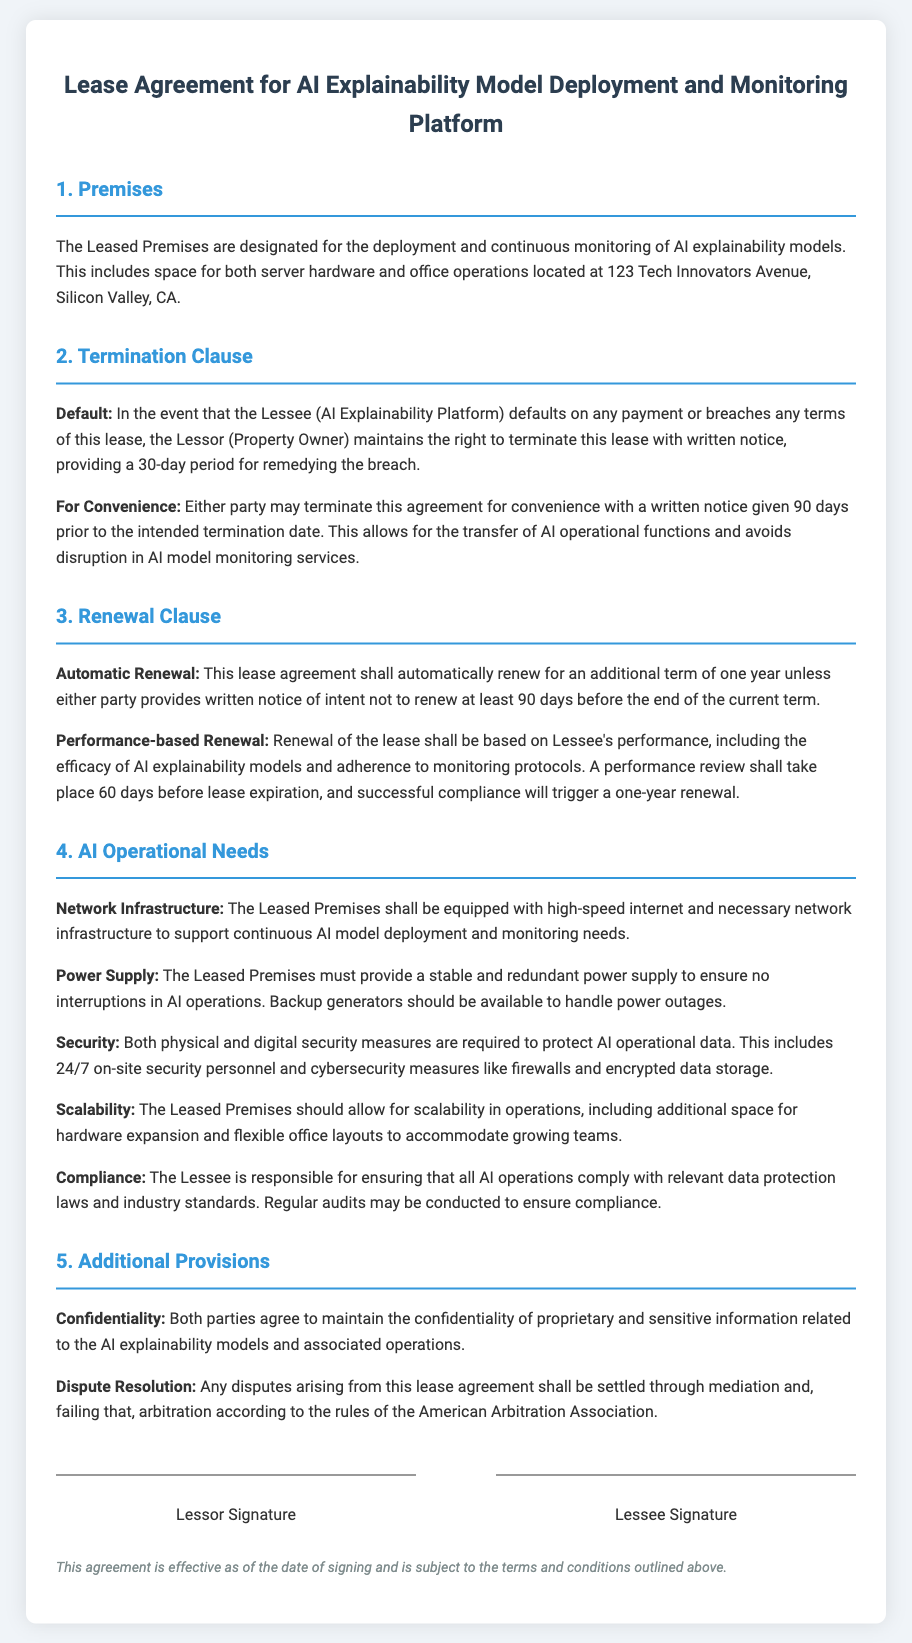What is the location of the leased premises? The document specifies the location of the leased premises as 123 Tech Innovators Avenue, Silicon Valley, CA.
Answer: 123 Tech Innovators Avenue, Silicon Valley, CA What is the notice period for terminating the lease for convenience? The lease can be terminated for convenience with a written notice given 90 days prior to the intended termination date.
Answer: 90 days What are the two conditions for automatic lease renewal? The lease will automatically renew unless either party provides written notice of intent not to renew at least 90 days before the end of the current term.
Answer: Written notice, 90 days What must the leased premises provide for AI operations? The leased premises must provide a stable and redundant power supply to ensure no interruptions in AI operations.
Answer: Stable and redundant power supply How many days before the lease expiration will the performance review take place? A performance review shall take place 60 days before lease expiration.
Answer: 60 days What is required to protect AI operational data? Both physical and digital security measures, including 24/7 on-site security personnel, are required to protect AI operational data.
Answer: 24/7 on-site security personnel What will happen if the lessee breaches any terms of the lease? If the lessee breaches any terms of the lease, the lessor maintains the right to terminate the lease with written notice.
Answer: Terminate the lease What will trigger a one-year renewal of the lease? Successful compliance with performance standards, including the efficacy of AI explainability models, will trigger a one-year renewal.
Answer: Efficacy of AI explainability models What is the document type? The document is a lease agreement for deploying and monitoring AI explainability models.
Answer: Lease Agreement 